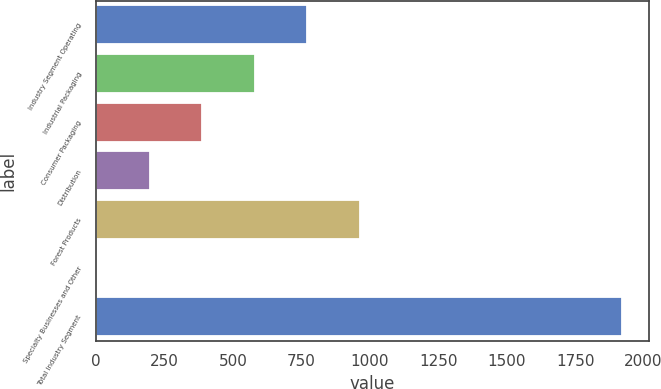Convert chart to OTSL. <chart><loc_0><loc_0><loc_500><loc_500><bar_chart><fcel>Industry Segment Operating<fcel>Industrial Packaging<fcel>Consumer Packaging<fcel>Distribution<fcel>Forest Products<fcel>Specialty Businesses and Other<fcel>Total Industry Segment<nl><fcel>771.6<fcel>579.7<fcel>387.8<fcel>195.9<fcel>963.5<fcel>4<fcel>1923<nl></chart> 